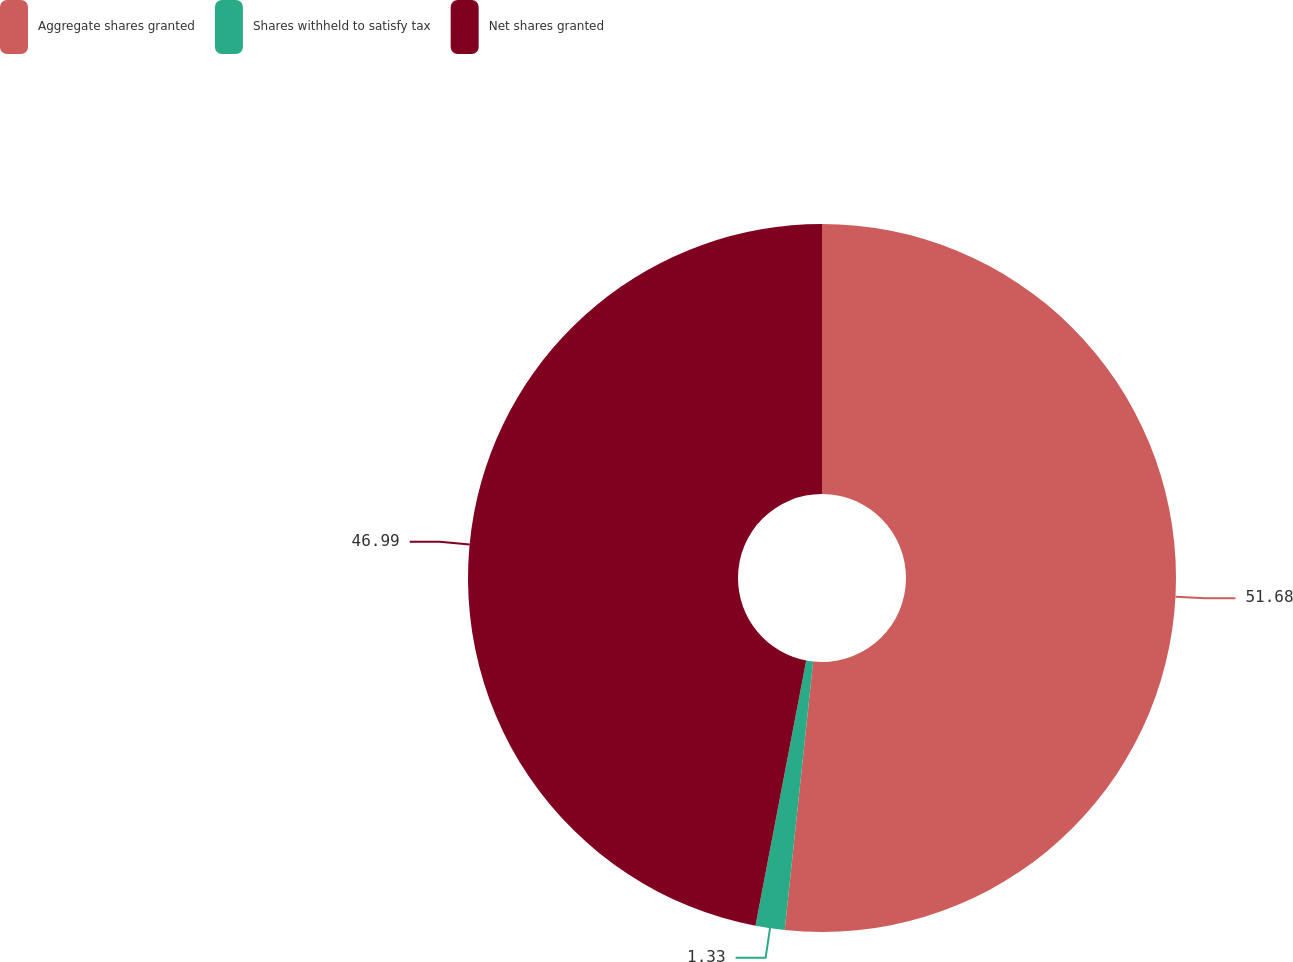Convert chart. <chart><loc_0><loc_0><loc_500><loc_500><pie_chart><fcel>Aggregate shares granted<fcel>Shares withheld to satisfy tax<fcel>Net shares granted<nl><fcel>51.68%<fcel>1.33%<fcel>46.99%<nl></chart> 